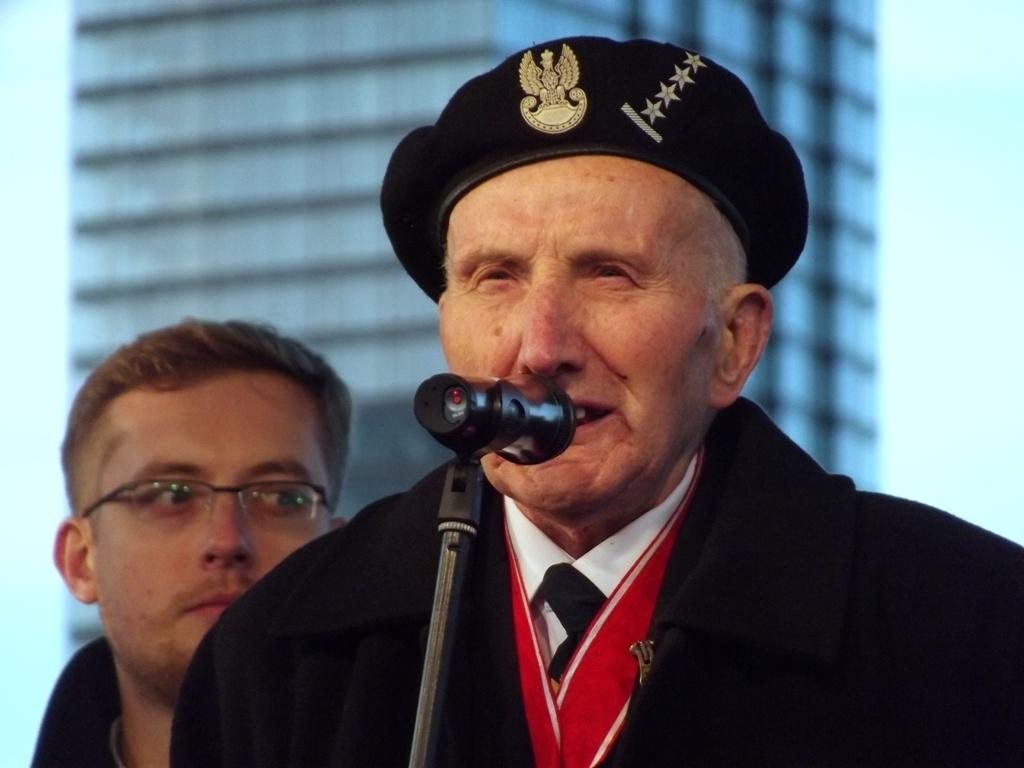What is the main subject of the image? There is a person standing at the mic in the center of the image. Can you describe the setting of the image? There is a person visible in the background and a building in the background. The sky is also visible in the background. What might the person at the mic be doing? The person at the mic might be singing, speaking, or performing in some way. What type of gun is visible in the image? There is no gun present in the image. What journey is the person at the mic embarking on in the image? There is no indication of a journey in the image; it simply shows a person at a mic with a background setting. 